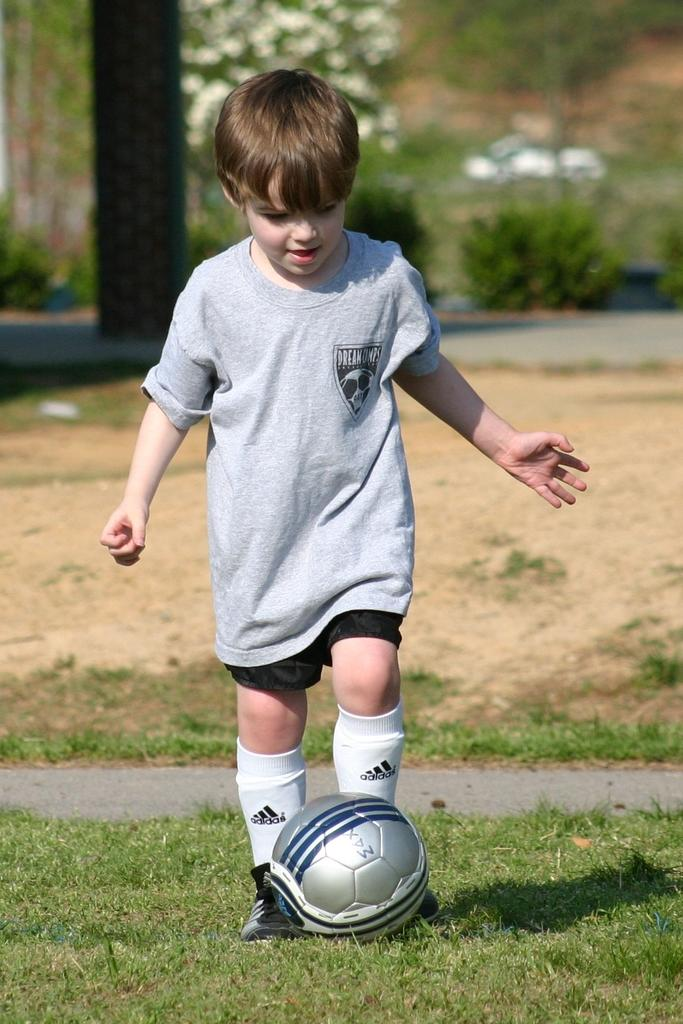Who is the main subject in the image? There is a boy in the image. What is the boy doing in the image? The boy is playing football. On what surface is the football being played? The football is being played on green grass. What can be seen in the background of the image? There are trees visible in the background of the image. Where is the boy's toothbrush in the image? There is no toothbrush present in the image. What type of field is the boy playing football on? The image does not specify the type of field, only that the football is being played on green grass. 